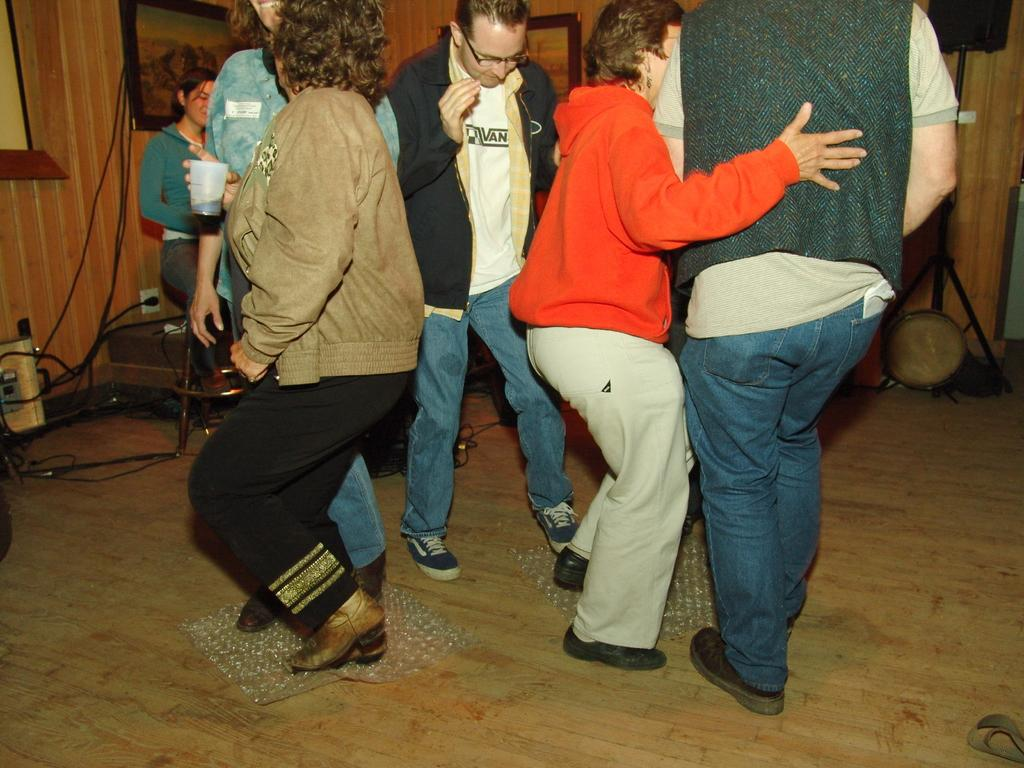How many persons are in the image? There are persons in the image, but the exact number is not specified. What is the primary surface visible in the image? The image shows a floor. What can be seen in the background of the image? In the background of the image, there are frames, a stand, a speaker, cables, and a wall. What type of equipment might be used for amplifying sound in the image? There is a speaker in the background of the image, which might be used for amplifying sound. What type of object might be used for organizing or displaying items in the image? The stand in the background of the image might be used for organizing or displaying items. What type of heart can be seen beating in the image? There is no heart visible in the image. 